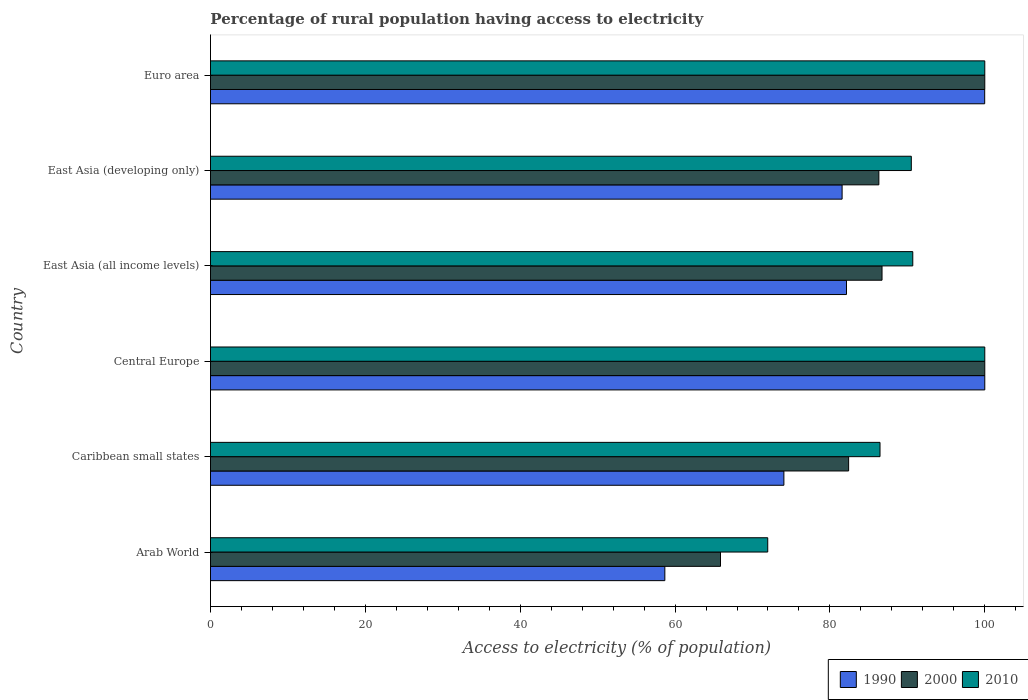What is the label of the 6th group of bars from the top?
Ensure brevity in your answer.  Arab World. In how many cases, is the number of bars for a given country not equal to the number of legend labels?
Offer a very short reply. 0. What is the percentage of rural population having access to electricity in 2010 in Central Europe?
Offer a terse response. 100. Across all countries, what is the minimum percentage of rural population having access to electricity in 2000?
Offer a terse response. 65.87. In which country was the percentage of rural population having access to electricity in 2010 maximum?
Your answer should be very brief. Central Europe. In which country was the percentage of rural population having access to electricity in 1990 minimum?
Give a very brief answer. Arab World. What is the total percentage of rural population having access to electricity in 2010 in the graph?
Give a very brief answer. 539.66. What is the difference between the percentage of rural population having access to electricity in 2000 in Caribbean small states and that in East Asia (all income levels)?
Keep it short and to the point. -4.31. What is the difference between the percentage of rural population having access to electricity in 1990 in Caribbean small states and the percentage of rural population having access to electricity in 2000 in East Asia (developing only)?
Your answer should be very brief. -12.27. What is the average percentage of rural population having access to electricity in 1990 per country?
Give a very brief answer. 82.74. What is the difference between the percentage of rural population having access to electricity in 2010 and percentage of rural population having access to electricity in 2000 in East Asia (all income levels)?
Your response must be concise. 3.97. What is the ratio of the percentage of rural population having access to electricity in 2010 in Caribbean small states to that in East Asia (developing only)?
Ensure brevity in your answer.  0.96. Is the percentage of rural population having access to electricity in 1990 in East Asia (all income levels) less than that in East Asia (developing only)?
Your answer should be compact. No. What is the difference between the highest and the second highest percentage of rural population having access to electricity in 2010?
Provide a succinct answer. 0. What is the difference between the highest and the lowest percentage of rural population having access to electricity in 2000?
Give a very brief answer. 34.13. Is the sum of the percentage of rural population having access to electricity in 1990 in Central Europe and East Asia (developing only) greater than the maximum percentage of rural population having access to electricity in 2010 across all countries?
Your answer should be very brief. Yes. What does the 2nd bar from the bottom in East Asia (all income levels) represents?
Ensure brevity in your answer.  2000. Are all the bars in the graph horizontal?
Your answer should be very brief. Yes. How many countries are there in the graph?
Your answer should be compact. 6. What is the difference between two consecutive major ticks on the X-axis?
Your answer should be compact. 20. Does the graph contain any zero values?
Ensure brevity in your answer.  No. Does the graph contain grids?
Offer a terse response. No. How many legend labels are there?
Your response must be concise. 3. How are the legend labels stacked?
Provide a short and direct response. Horizontal. What is the title of the graph?
Offer a very short reply. Percentage of rural population having access to electricity. Does "1982" appear as one of the legend labels in the graph?
Provide a short and direct response. No. What is the label or title of the X-axis?
Ensure brevity in your answer.  Access to electricity (% of population). What is the Access to electricity (% of population) in 1990 in Arab World?
Your answer should be very brief. 58.68. What is the Access to electricity (% of population) of 2000 in Arab World?
Your response must be concise. 65.87. What is the Access to electricity (% of population) in 2010 in Arab World?
Ensure brevity in your answer.  71.97. What is the Access to electricity (% of population) of 1990 in Caribbean small states?
Provide a succinct answer. 74.06. What is the Access to electricity (% of population) of 2000 in Caribbean small states?
Make the answer very short. 82.42. What is the Access to electricity (% of population) in 2010 in Caribbean small states?
Keep it short and to the point. 86.47. What is the Access to electricity (% of population) of 2010 in Central Europe?
Provide a short and direct response. 100. What is the Access to electricity (% of population) of 1990 in East Asia (all income levels)?
Offer a terse response. 82.14. What is the Access to electricity (% of population) of 2000 in East Asia (all income levels)?
Your response must be concise. 86.73. What is the Access to electricity (% of population) in 2010 in East Asia (all income levels)?
Make the answer very short. 90.7. What is the Access to electricity (% of population) of 1990 in East Asia (developing only)?
Provide a short and direct response. 81.57. What is the Access to electricity (% of population) in 2000 in East Asia (developing only)?
Offer a terse response. 86.32. What is the Access to electricity (% of population) in 2010 in East Asia (developing only)?
Ensure brevity in your answer.  90.51. What is the Access to electricity (% of population) in 1990 in Euro area?
Provide a succinct answer. 99.99. What is the Access to electricity (% of population) in 2000 in Euro area?
Offer a very short reply. 100. Across all countries, what is the maximum Access to electricity (% of population) in 2010?
Give a very brief answer. 100. Across all countries, what is the minimum Access to electricity (% of population) of 1990?
Provide a succinct answer. 58.68. Across all countries, what is the minimum Access to electricity (% of population) in 2000?
Provide a short and direct response. 65.87. Across all countries, what is the minimum Access to electricity (% of population) in 2010?
Offer a very short reply. 71.97. What is the total Access to electricity (% of population) in 1990 in the graph?
Keep it short and to the point. 496.44. What is the total Access to electricity (% of population) in 2000 in the graph?
Provide a short and direct response. 521.34. What is the total Access to electricity (% of population) in 2010 in the graph?
Provide a succinct answer. 539.66. What is the difference between the Access to electricity (% of population) in 1990 in Arab World and that in Caribbean small states?
Provide a succinct answer. -15.38. What is the difference between the Access to electricity (% of population) of 2000 in Arab World and that in Caribbean small states?
Offer a terse response. -16.55. What is the difference between the Access to electricity (% of population) of 2010 in Arab World and that in Caribbean small states?
Ensure brevity in your answer.  -14.5. What is the difference between the Access to electricity (% of population) of 1990 in Arab World and that in Central Europe?
Offer a terse response. -41.32. What is the difference between the Access to electricity (% of population) of 2000 in Arab World and that in Central Europe?
Make the answer very short. -34.13. What is the difference between the Access to electricity (% of population) of 2010 in Arab World and that in Central Europe?
Your response must be concise. -28.03. What is the difference between the Access to electricity (% of population) in 1990 in Arab World and that in East Asia (all income levels)?
Offer a terse response. -23.46. What is the difference between the Access to electricity (% of population) of 2000 in Arab World and that in East Asia (all income levels)?
Provide a short and direct response. -20.86. What is the difference between the Access to electricity (% of population) in 2010 in Arab World and that in East Asia (all income levels)?
Keep it short and to the point. -18.73. What is the difference between the Access to electricity (% of population) in 1990 in Arab World and that in East Asia (developing only)?
Ensure brevity in your answer.  -22.89. What is the difference between the Access to electricity (% of population) in 2000 in Arab World and that in East Asia (developing only)?
Give a very brief answer. -20.45. What is the difference between the Access to electricity (% of population) of 2010 in Arab World and that in East Asia (developing only)?
Your answer should be compact. -18.54. What is the difference between the Access to electricity (% of population) in 1990 in Arab World and that in Euro area?
Your answer should be very brief. -41.31. What is the difference between the Access to electricity (% of population) in 2000 in Arab World and that in Euro area?
Provide a short and direct response. -34.13. What is the difference between the Access to electricity (% of population) in 2010 in Arab World and that in Euro area?
Provide a short and direct response. -28.03. What is the difference between the Access to electricity (% of population) of 1990 in Caribbean small states and that in Central Europe?
Provide a short and direct response. -25.94. What is the difference between the Access to electricity (% of population) in 2000 in Caribbean small states and that in Central Europe?
Keep it short and to the point. -17.58. What is the difference between the Access to electricity (% of population) of 2010 in Caribbean small states and that in Central Europe?
Ensure brevity in your answer.  -13.53. What is the difference between the Access to electricity (% of population) of 1990 in Caribbean small states and that in East Asia (all income levels)?
Keep it short and to the point. -8.09. What is the difference between the Access to electricity (% of population) in 2000 in Caribbean small states and that in East Asia (all income levels)?
Ensure brevity in your answer.  -4.31. What is the difference between the Access to electricity (% of population) in 2010 in Caribbean small states and that in East Asia (all income levels)?
Offer a very short reply. -4.23. What is the difference between the Access to electricity (% of population) in 1990 in Caribbean small states and that in East Asia (developing only)?
Ensure brevity in your answer.  -7.52. What is the difference between the Access to electricity (% of population) of 2000 in Caribbean small states and that in East Asia (developing only)?
Provide a succinct answer. -3.91. What is the difference between the Access to electricity (% of population) of 2010 in Caribbean small states and that in East Asia (developing only)?
Offer a terse response. -4.04. What is the difference between the Access to electricity (% of population) in 1990 in Caribbean small states and that in Euro area?
Your answer should be very brief. -25.93. What is the difference between the Access to electricity (% of population) in 2000 in Caribbean small states and that in Euro area?
Your answer should be very brief. -17.58. What is the difference between the Access to electricity (% of population) of 2010 in Caribbean small states and that in Euro area?
Ensure brevity in your answer.  -13.53. What is the difference between the Access to electricity (% of population) of 1990 in Central Europe and that in East Asia (all income levels)?
Your answer should be compact. 17.86. What is the difference between the Access to electricity (% of population) in 2000 in Central Europe and that in East Asia (all income levels)?
Your answer should be very brief. 13.27. What is the difference between the Access to electricity (% of population) in 2010 in Central Europe and that in East Asia (all income levels)?
Make the answer very short. 9.3. What is the difference between the Access to electricity (% of population) of 1990 in Central Europe and that in East Asia (developing only)?
Your response must be concise. 18.43. What is the difference between the Access to electricity (% of population) in 2000 in Central Europe and that in East Asia (developing only)?
Your answer should be compact. 13.68. What is the difference between the Access to electricity (% of population) of 2010 in Central Europe and that in East Asia (developing only)?
Make the answer very short. 9.49. What is the difference between the Access to electricity (% of population) in 1990 in Central Europe and that in Euro area?
Keep it short and to the point. 0.01. What is the difference between the Access to electricity (% of population) in 2000 in Central Europe and that in Euro area?
Ensure brevity in your answer.  0. What is the difference between the Access to electricity (% of population) in 1990 in East Asia (all income levels) and that in East Asia (developing only)?
Your response must be concise. 0.57. What is the difference between the Access to electricity (% of population) in 2000 in East Asia (all income levels) and that in East Asia (developing only)?
Offer a terse response. 0.41. What is the difference between the Access to electricity (% of population) in 2010 in East Asia (all income levels) and that in East Asia (developing only)?
Your response must be concise. 0.19. What is the difference between the Access to electricity (% of population) of 1990 in East Asia (all income levels) and that in Euro area?
Offer a very short reply. -17.85. What is the difference between the Access to electricity (% of population) in 2000 in East Asia (all income levels) and that in Euro area?
Ensure brevity in your answer.  -13.27. What is the difference between the Access to electricity (% of population) of 2010 in East Asia (all income levels) and that in Euro area?
Keep it short and to the point. -9.3. What is the difference between the Access to electricity (% of population) of 1990 in East Asia (developing only) and that in Euro area?
Keep it short and to the point. -18.41. What is the difference between the Access to electricity (% of population) of 2000 in East Asia (developing only) and that in Euro area?
Provide a succinct answer. -13.68. What is the difference between the Access to electricity (% of population) of 2010 in East Asia (developing only) and that in Euro area?
Provide a succinct answer. -9.49. What is the difference between the Access to electricity (% of population) in 1990 in Arab World and the Access to electricity (% of population) in 2000 in Caribbean small states?
Offer a very short reply. -23.74. What is the difference between the Access to electricity (% of population) in 1990 in Arab World and the Access to electricity (% of population) in 2010 in Caribbean small states?
Offer a terse response. -27.79. What is the difference between the Access to electricity (% of population) of 2000 in Arab World and the Access to electricity (% of population) of 2010 in Caribbean small states?
Ensure brevity in your answer.  -20.6. What is the difference between the Access to electricity (% of population) in 1990 in Arab World and the Access to electricity (% of population) in 2000 in Central Europe?
Provide a succinct answer. -41.32. What is the difference between the Access to electricity (% of population) of 1990 in Arab World and the Access to electricity (% of population) of 2010 in Central Europe?
Keep it short and to the point. -41.32. What is the difference between the Access to electricity (% of population) in 2000 in Arab World and the Access to electricity (% of population) in 2010 in Central Europe?
Your answer should be very brief. -34.13. What is the difference between the Access to electricity (% of population) of 1990 in Arab World and the Access to electricity (% of population) of 2000 in East Asia (all income levels)?
Offer a terse response. -28.05. What is the difference between the Access to electricity (% of population) in 1990 in Arab World and the Access to electricity (% of population) in 2010 in East Asia (all income levels)?
Provide a succinct answer. -32.02. What is the difference between the Access to electricity (% of population) of 2000 in Arab World and the Access to electricity (% of population) of 2010 in East Asia (all income levels)?
Your answer should be very brief. -24.83. What is the difference between the Access to electricity (% of population) in 1990 in Arab World and the Access to electricity (% of population) in 2000 in East Asia (developing only)?
Offer a terse response. -27.64. What is the difference between the Access to electricity (% of population) in 1990 in Arab World and the Access to electricity (% of population) in 2010 in East Asia (developing only)?
Keep it short and to the point. -31.83. What is the difference between the Access to electricity (% of population) in 2000 in Arab World and the Access to electricity (% of population) in 2010 in East Asia (developing only)?
Offer a very short reply. -24.64. What is the difference between the Access to electricity (% of population) in 1990 in Arab World and the Access to electricity (% of population) in 2000 in Euro area?
Offer a terse response. -41.32. What is the difference between the Access to electricity (% of population) of 1990 in Arab World and the Access to electricity (% of population) of 2010 in Euro area?
Your answer should be compact. -41.32. What is the difference between the Access to electricity (% of population) of 2000 in Arab World and the Access to electricity (% of population) of 2010 in Euro area?
Your answer should be very brief. -34.13. What is the difference between the Access to electricity (% of population) in 1990 in Caribbean small states and the Access to electricity (% of population) in 2000 in Central Europe?
Offer a terse response. -25.94. What is the difference between the Access to electricity (% of population) of 1990 in Caribbean small states and the Access to electricity (% of population) of 2010 in Central Europe?
Provide a short and direct response. -25.94. What is the difference between the Access to electricity (% of population) in 2000 in Caribbean small states and the Access to electricity (% of population) in 2010 in Central Europe?
Offer a terse response. -17.58. What is the difference between the Access to electricity (% of population) in 1990 in Caribbean small states and the Access to electricity (% of population) in 2000 in East Asia (all income levels)?
Provide a short and direct response. -12.67. What is the difference between the Access to electricity (% of population) of 1990 in Caribbean small states and the Access to electricity (% of population) of 2010 in East Asia (all income levels)?
Offer a terse response. -16.65. What is the difference between the Access to electricity (% of population) of 2000 in Caribbean small states and the Access to electricity (% of population) of 2010 in East Asia (all income levels)?
Make the answer very short. -8.29. What is the difference between the Access to electricity (% of population) of 1990 in Caribbean small states and the Access to electricity (% of population) of 2000 in East Asia (developing only)?
Your answer should be compact. -12.27. What is the difference between the Access to electricity (% of population) in 1990 in Caribbean small states and the Access to electricity (% of population) in 2010 in East Asia (developing only)?
Keep it short and to the point. -16.46. What is the difference between the Access to electricity (% of population) in 2000 in Caribbean small states and the Access to electricity (% of population) in 2010 in East Asia (developing only)?
Your answer should be very brief. -8.1. What is the difference between the Access to electricity (% of population) of 1990 in Caribbean small states and the Access to electricity (% of population) of 2000 in Euro area?
Offer a very short reply. -25.94. What is the difference between the Access to electricity (% of population) in 1990 in Caribbean small states and the Access to electricity (% of population) in 2010 in Euro area?
Your answer should be very brief. -25.94. What is the difference between the Access to electricity (% of population) of 2000 in Caribbean small states and the Access to electricity (% of population) of 2010 in Euro area?
Offer a terse response. -17.58. What is the difference between the Access to electricity (% of population) in 1990 in Central Europe and the Access to electricity (% of population) in 2000 in East Asia (all income levels)?
Your answer should be very brief. 13.27. What is the difference between the Access to electricity (% of population) in 1990 in Central Europe and the Access to electricity (% of population) in 2010 in East Asia (all income levels)?
Your response must be concise. 9.3. What is the difference between the Access to electricity (% of population) in 2000 in Central Europe and the Access to electricity (% of population) in 2010 in East Asia (all income levels)?
Your response must be concise. 9.3. What is the difference between the Access to electricity (% of population) of 1990 in Central Europe and the Access to electricity (% of population) of 2000 in East Asia (developing only)?
Make the answer very short. 13.68. What is the difference between the Access to electricity (% of population) in 1990 in Central Europe and the Access to electricity (% of population) in 2010 in East Asia (developing only)?
Provide a short and direct response. 9.49. What is the difference between the Access to electricity (% of population) in 2000 in Central Europe and the Access to electricity (% of population) in 2010 in East Asia (developing only)?
Your response must be concise. 9.49. What is the difference between the Access to electricity (% of population) of 1990 in Central Europe and the Access to electricity (% of population) of 2000 in Euro area?
Provide a short and direct response. 0. What is the difference between the Access to electricity (% of population) of 2000 in Central Europe and the Access to electricity (% of population) of 2010 in Euro area?
Keep it short and to the point. 0. What is the difference between the Access to electricity (% of population) of 1990 in East Asia (all income levels) and the Access to electricity (% of population) of 2000 in East Asia (developing only)?
Offer a terse response. -4.18. What is the difference between the Access to electricity (% of population) of 1990 in East Asia (all income levels) and the Access to electricity (% of population) of 2010 in East Asia (developing only)?
Give a very brief answer. -8.37. What is the difference between the Access to electricity (% of population) in 2000 in East Asia (all income levels) and the Access to electricity (% of population) in 2010 in East Asia (developing only)?
Your answer should be very brief. -3.78. What is the difference between the Access to electricity (% of population) in 1990 in East Asia (all income levels) and the Access to electricity (% of population) in 2000 in Euro area?
Your answer should be compact. -17.86. What is the difference between the Access to electricity (% of population) of 1990 in East Asia (all income levels) and the Access to electricity (% of population) of 2010 in Euro area?
Provide a succinct answer. -17.86. What is the difference between the Access to electricity (% of population) of 2000 in East Asia (all income levels) and the Access to electricity (% of population) of 2010 in Euro area?
Give a very brief answer. -13.27. What is the difference between the Access to electricity (% of population) of 1990 in East Asia (developing only) and the Access to electricity (% of population) of 2000 in Euro area?
Ensure brevity in your answer.  -18.43. What is the difference between the Access to electricity (% of population) of 1990 in East Asia (developing only) and the Access to electricity (% of population) of 2010 in Euro area?
Give a very brief answer. -18.43. What is the difference between the Access to electricity (% of population) of 2000 in East Asia (developing only) and the Access to electricity (% of population) of 2010 in Euro area?
Provide a succinct answer. -13.68. What is the average Access to electricity (% of population) in 1990 per country?
Provide a succinct answer. 82.74. What is the average Access to electricity (% of population) of 2000 per country?
Provide a succinct answer. 86.89. What is the average Access to electricity (% of population) of 2010 per country?
Make the answer very short. 89.94. What is the difference between the Access to electricity (% of population) in 1990 and Access to electricity (% of population) in 2000 in Arab World?
Keep it short and to the point. -7.19. What is the difference between the Access to electricity (% of population) in 1990 and Access to electricity (% of population) in 2010 in Arab World?
Give a very brief answer. -13.29. What is the difference between the Access to electricity (% of population) in 2000 and Access to electricity (% of population) in 2010 in Arab World?
Offer a terse response. -6.1. What is the difference between the Access to electricity (% of population) of 1990 and Access to electricity (% of population) of 2000 in Caribbean small states?
Your answer should be very brief. -8.36. What is the difference between the Access to electricity (% of population) of 1990 and Access to electricity (% of population) of 2010 in Caribbean small states?
Your answer should be very brief. -12.41. What is the difference between the Access to electricity (% of population) in 2000 and Access to electricity (% of population) in 2010 in Caribbean small states?
Keep it short and to the point. -4.05. What is the difference between the Access to electricity (% of population) of 1990 and Access to electricity (% of population) of 2000 in Central Europe?
Ensure brevity in your answer.  0. What is the difference between the Access to electricity (% of population) in 2000 and Access to electricity (% of population) in 2010 in Central Europe?
Offer a very short reply. 0. What is the difference between the Access to electricity (% of population) in 1990 and Access to electricity (% of population) in 2000 in East Asia (all income levels)?
Your response must be concise. -4.59. What is the difference between the Access to electricity (% of population) in 1990 and Access to electricity (% of population) in 2010 in East Asia (all income levels)?
Provide a short and direct response. -8.56. What is the difference between the Access to electricity (% of population) in 2000 and Access to electricity (% of population) in 2010 in East Asia (all income levels)?
Keep it short and to the point. -3.97. What is the difference between the Access to electricity (% of population) in 1990 and Access to electricity (% of population) in 2000 in East Asia (developing only)?
Ensure brevity in your answer.  -4.75. What is the difference between the Access to electricity (% of population) in 1990 and Access to electricity (% of population) in 2010 in East Asia (developing only)?
Your answer should be very brief. -8.94. What is the difference between the Access to electricity (% of population) in 2000 and Access to electricity (% of population) in 2010 in East Asia (developing only)?
Provide a short and direct response. -4.19. What is the difference between the Access to electricity (% of population) in 1990 and Access to electricity (% of population) in 2000 in Euro area?
Make the answer very short. -0.01. What is the difference between the Access to electricity (% of population) in 1990 and Access to electricity (% of population) in 2010 in Euro area?
Offer a terse response. -0.01. What is the difference between the Access to electricity (% of population) in 2000 and Access to electricity (% of population) in 2010 in Euro area?
Give a very brief answer. 0. What is the ratio of the Access to electricity (% of population) in 1990 in Arab World to that in Caribbean small states?
Provide a succinct answer. 0.79. What is the ratio of the Access to electricity (% of population) of 2000 in Arab World to that in Caribbean small states?
Offer a terse response. 0.8. What is the ratio of the Access to electricity (% of population) in 2010 in Arab World to that in Caribbean small states?
Make the answer very short. 0.83. What is the ratio of the Access to electricity (% of population) in 1990 in Arab World to that in Central Europe?
Offer a very short reply. 0.59. What is the ratio of the Access to electricity (% of population) of 2000 in Arab World to that in Central Europe?
Your answer should be very brief. 0.66. What is the ratio of the Access to electricity (% of population) of 2010 in Arab World to that in Central Europe?
Give a very brief answer. 0.72. What is the ratio of the Access to electricity (% of population) of 1990 in Arab World to that in East Asia (all income levels)?
Provide a succinct answer. 0.71. What is the ratio of the Access to electricity (% of population) of 2000 in Arab World to that in East Asia (all income levels)?
Keep it short and to the point. 0.76. What is the ratio of the Access to electricity (% of population) in 2010 in Arab World to that in East Asia (all income levels)?
Offer a very short reply. 0.79. What is the ratio of the Access to electricity (% of population) in 1990 in Arab World to that in East Asia (developing only)?
Offer a terse response. 0.72. What is the ratio of the Access to electricity (% of population) in 2000 in Arab World to that in East Asia (developing only)?
Ensure brevity in your answer.  0.76. What is the ratio of the Access to electricity (% of population) in 2010 in Arab World to that in East Asia (developing only)?
Make the answer very short. 0.8. What is the ratio of the Access to electricity (% of population) of 1990 in Arab World to that in Euro area?
Offer a terse response. 0.59. What is the ratio of the Access to electricity (% of population) of 2000 in Arab World to that in Euro area?
Your answer should be very brief. 0.66. What is the ratio of the Access to electricity (% of population) of 2010 in Arab World to that in Euro area?
Offer a terse response. 0.72. What is the ratio of the Access to electricity (% of population) in 1990 in Caribbean small states to that in Central Europe?
Offer a terse response. 0.74. What is the ratio of the Access to electricity (% of population) in 2000 in Caribbean small states to that in Central Europe?
Your answer should be very brief. 0.82. What is the ratio of the Access to electricity (% of population) of 2010 in Caribbean small states to that in Central Europe?
Keep it short and to the point. 0.86. What is the ratio of the Access to electricity (% of population) in 1990 in Caribbean small states to that in East Asia (all income levels)?
Provide a short and direct response. 0.9. What is the ratio of the Access to electricity (% of population) of 2000 in Caribbean small states to that in East Asia (all income levels)?
Your answer should be compact. 0.95. What is the ratio of the Access to electricity (% of population) of 2010 in Caribbean small states to that in East Asia (all income levels)?
Provide a short and direct response. 0.95. What is the ratio of the Access to electricity (% of population) of 1990 in Caribbean small states to that in East Asia (developing only)?
Keep it short and to the point. 0.91. What is the ratio of the Access to electricity (% of population) of 2000 in Caribbean small states to that in East Asia (developing only)?
Ensure brevity in your answer.  0.95. What is the ratio of the Access to electricity (% of population) in 2010 in Caribbean small states to that in East Asia (developing only)?
Your response must be concise. 0.96. What is the ratio of the Access to electricity (% of population) of 1990 in Caribbean small states to that in Euro area?
Offer a very short reply. 0.74. What is the ratio of the Access to electricity (% of population) of 2000 in Caribbean small states to that in Euro area?
Offer a very short reply. 0.82. What is the ratio of the Access to electricity (% of population) of 2010 in Caribbean small states to that in Euro area?
Ensure brevity in your answer.  0.86. What is the ratio of the Access to electricity (% of population) in 1990 in Central Europe to that in East Asia (all income levels)?
Offer a very short reply. 1.22. What is the ratio of the Access to electricity (% of population) of 2000 in Central Europe to that in East Asia (all income levels)?
Keep it short and to the point. 1.15. What is the ratio of the Access to electricity (% of population) of 2010 in Central Europe to that in East Asia (all income levels)?
Keep it short and to the point. 1.1. What is the ratio of the Access to electricity (% of population) in 1990 in Central Europe to that in East Asia (developing only)?
Offer a terse response. 1.23. What is the ratio of the Access to electricity (% of population) in 2000 in Central Europe to that in East Asia (developing only)?
Your answer should be compact. 1.16. What is the ratio of the Access to electricity (% of population) in 2010 in Central Europe to that in East Asia (developing only)?
Keep it short and to the point. 1.1. What is the ratio of the Access to electricity (% of population) of 1990 in Central Europe to that in Euro area?
Your answer should be compact. 1. What is the ratio of the Access to electricity (% of population) in 1990 in East Asia (all income levels) to that in East Asia (developing only)?
Your answer should be compact. 1.01. What is the ratio of the Access to electricity (% of population) of 2010 in East Asia (all income levels) to that in East Asia (developing only)?
Give a very brief answer. 1. What is the ratio of the Access to electricity (% of population) in 1990 in East Asia (all income levels) to that in Euro area?
Give a very brief answer. 0.82. What is the ratio of the Access to electricity (% of population) of 2000 in East Asia (all income levels) to that in Euro area?
Offer a terse response. 0.87. What is the ratio of the Access to electricity (% of population) in 2010 in East Asia (all income levels) to that in Euro area?
Offer a very short reply. 0.91. What is the ratio of the Access to electricity (% of population) of 1990 in East Asia (developing only) to that in Euro area?
Your response must be concise. 0.82. What is the ratio of the Access to electricity (% of population) of 2000 in East Asia (developing only) to that in Euro area?
Give a very brief answer. 0.86. What is the ratio of the Access to electricity (% of population) of 2010 in East Asia (developing only) to that in Euro area?
Offer a very short reply. 0.91. What is the difference between the highest and the second highest Access to electricity (% of population) in 1990?
Provide a short and direct response. 0.01. What is the difference between the highest and the second highest Access to electricity (% of population) in 2000?
Provide a succinct answer. 0. What is the difference between the highest and the lowest Access to electricity (% of population) of 1990?
Your answer should be very brief. 41.32. What is the difference between the highest and the lowest Access to electricity (% of population) in 2000?
Provide a short and direct response. 34.13. What is the difference between the highest and the lowest Access to electricity (% of population) of 2010?
Your answer should be compact. 28.03. 